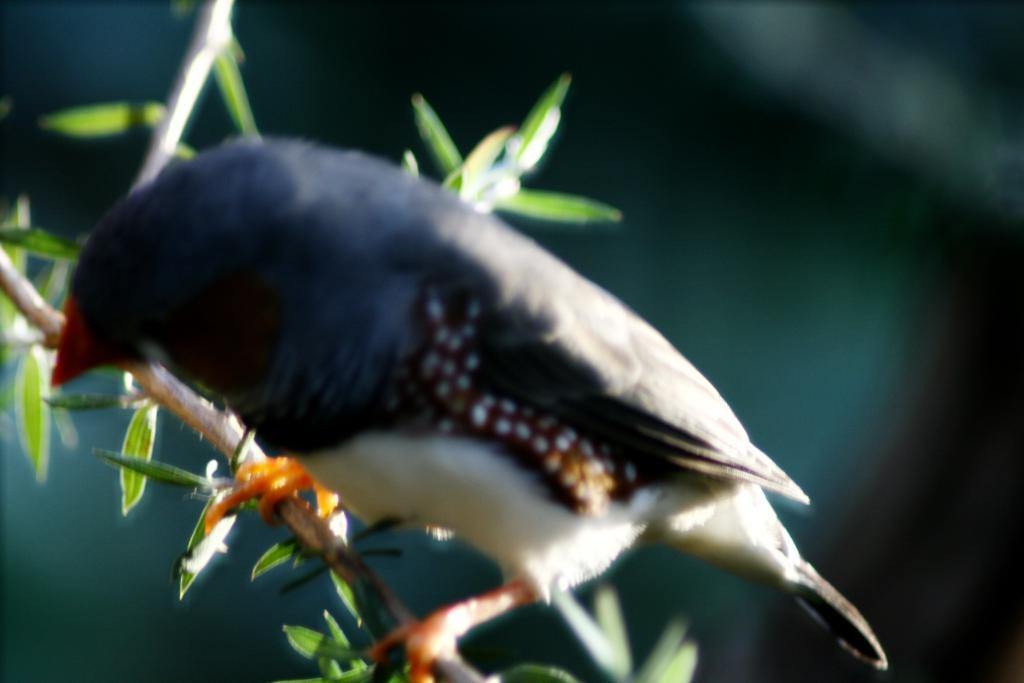Please provide a concise description of this image. In this picture there is a bird standing on the tree branch. At the back the image is blurry. 